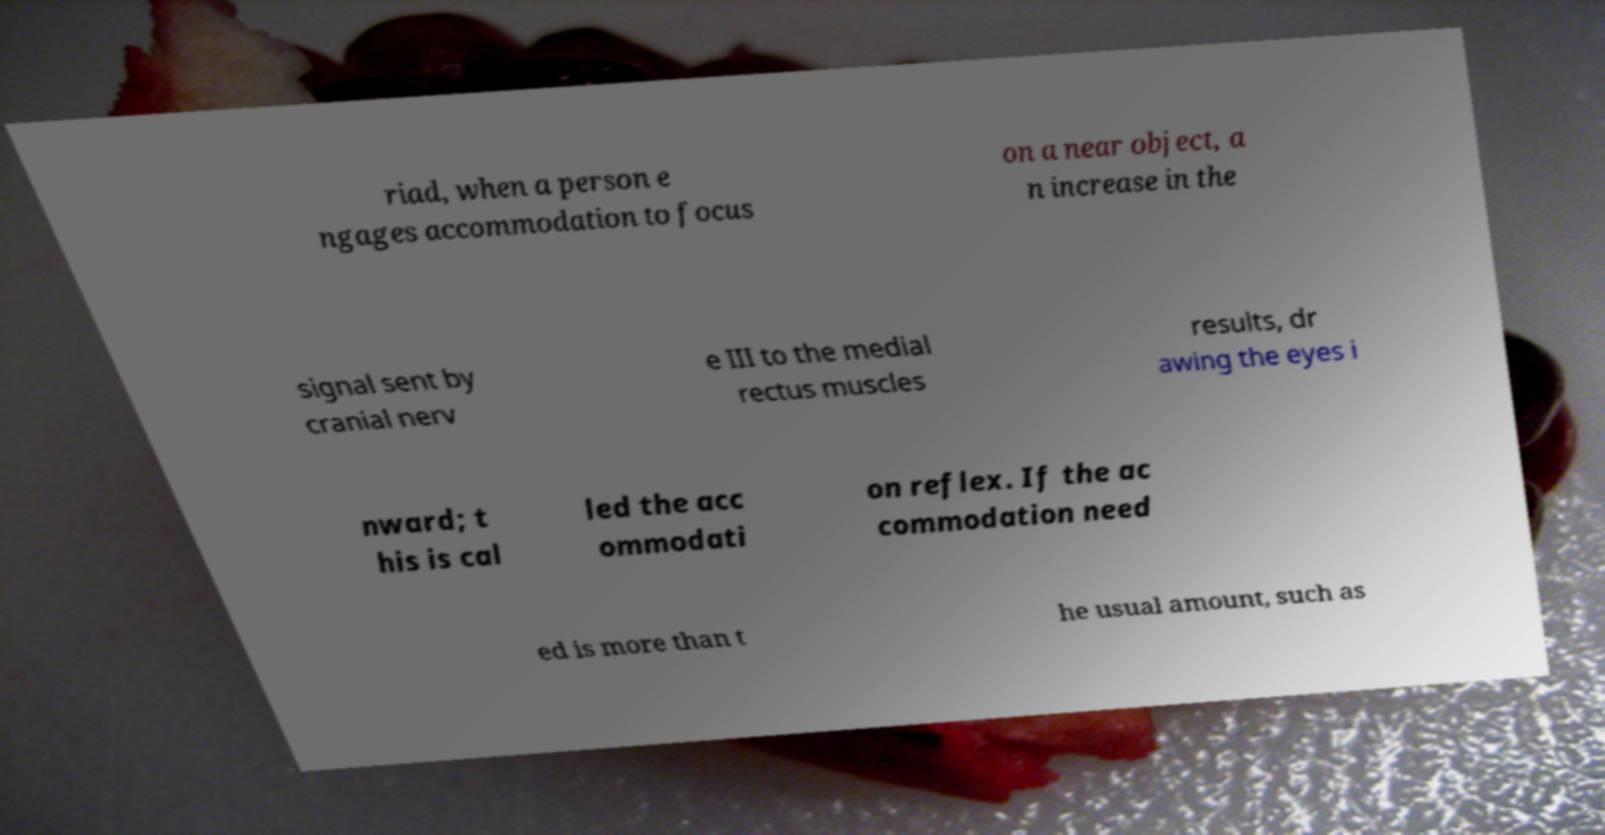I need the written content from this picture converted into text. Can you do that? riad, when a person e ngages accommodation to focus on a near object, a n increase in the signal sent by cranial nerv e III to the medial rectus muscles results, dr awing the eyes i nward; t his is cal led the acc ommodati on reflex. If the ac commodation need ed is more than t he usual amount, such as 